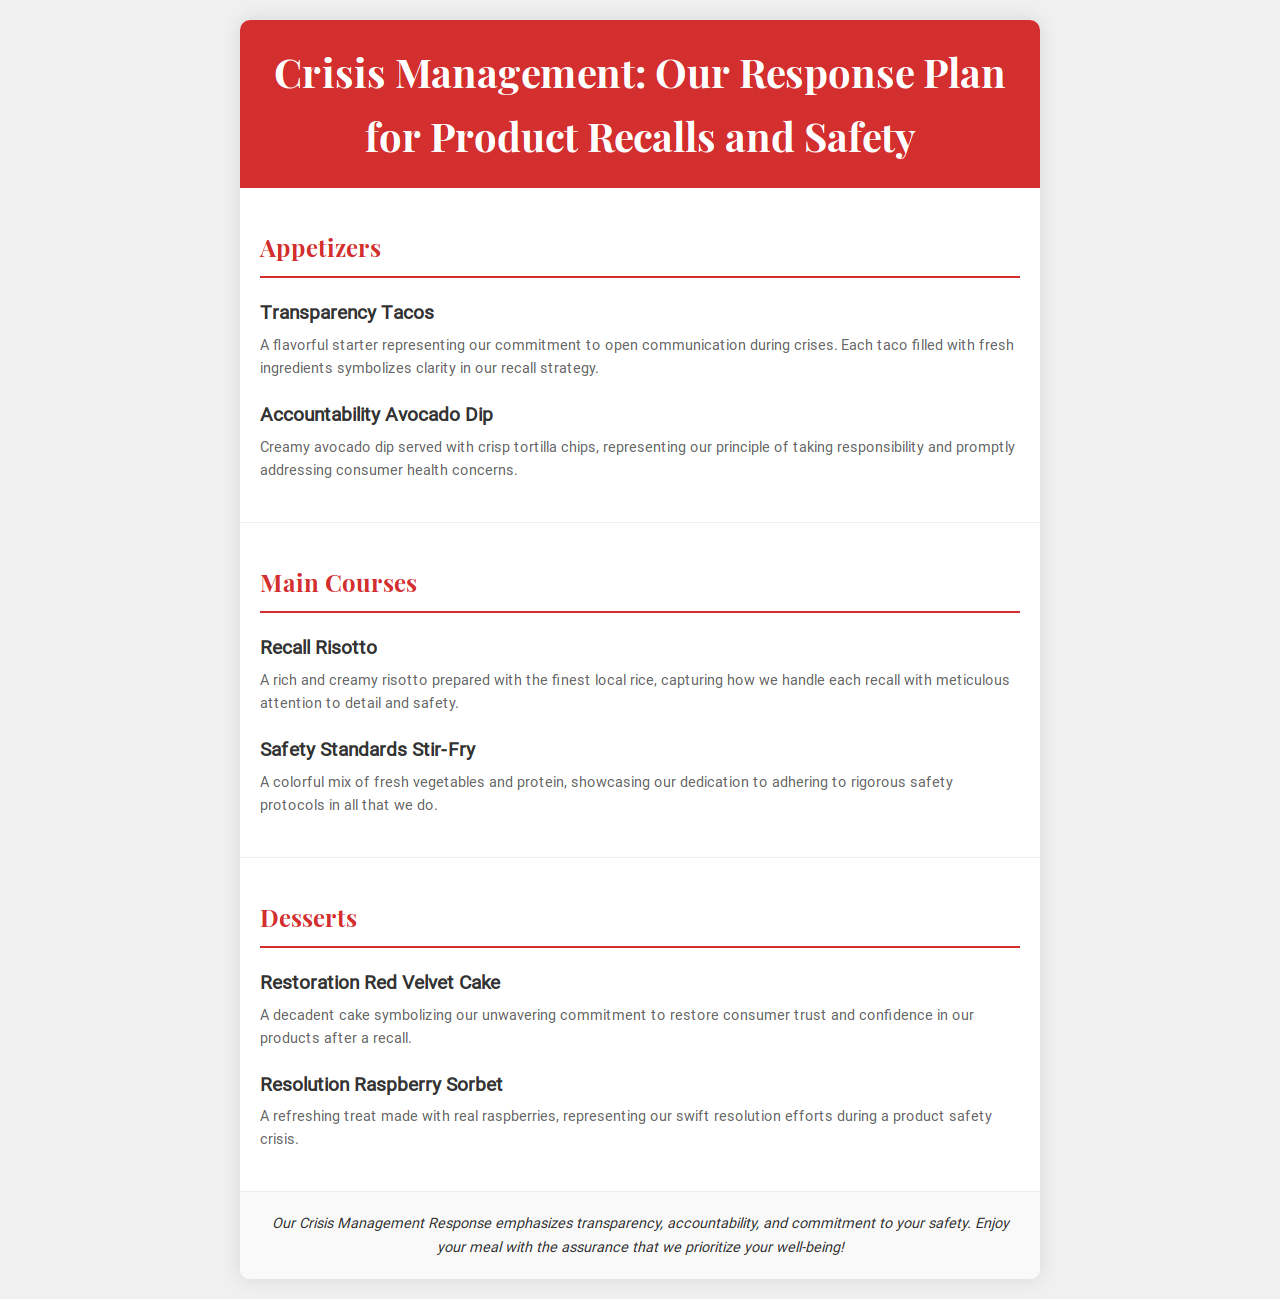What is the title of the document? The title is prominently displayed at the top of the document.
Answer: Crisis Management: Our Response Plan for Product Recalls and Safety What is the first appetizer listed? The menus typically list items in order, the first appetizer listed is mentioned in the appetizers section.
Answer: Transparency Tacos What does the Recall Risotto symbolize? The description of the dish provides insight into its symbolic meaning within the crisis management context.
Answer: Handling recalls with meticulous attention to detail and safety How many main courses are there? The number of dishes can be determined by counting the entries in the Main Courses section.
Answer: Two What is the primary focus of the closing statement? The closing statement summarizes the overall message of the document, addressing consumer concerns.
Answer: Prioritize your well-being! What main ingredient is used in the Resolution Raspberry Sorbet? The description of the dessert includes the main fruit component used in the recipe.
Answer: Real raspberries 